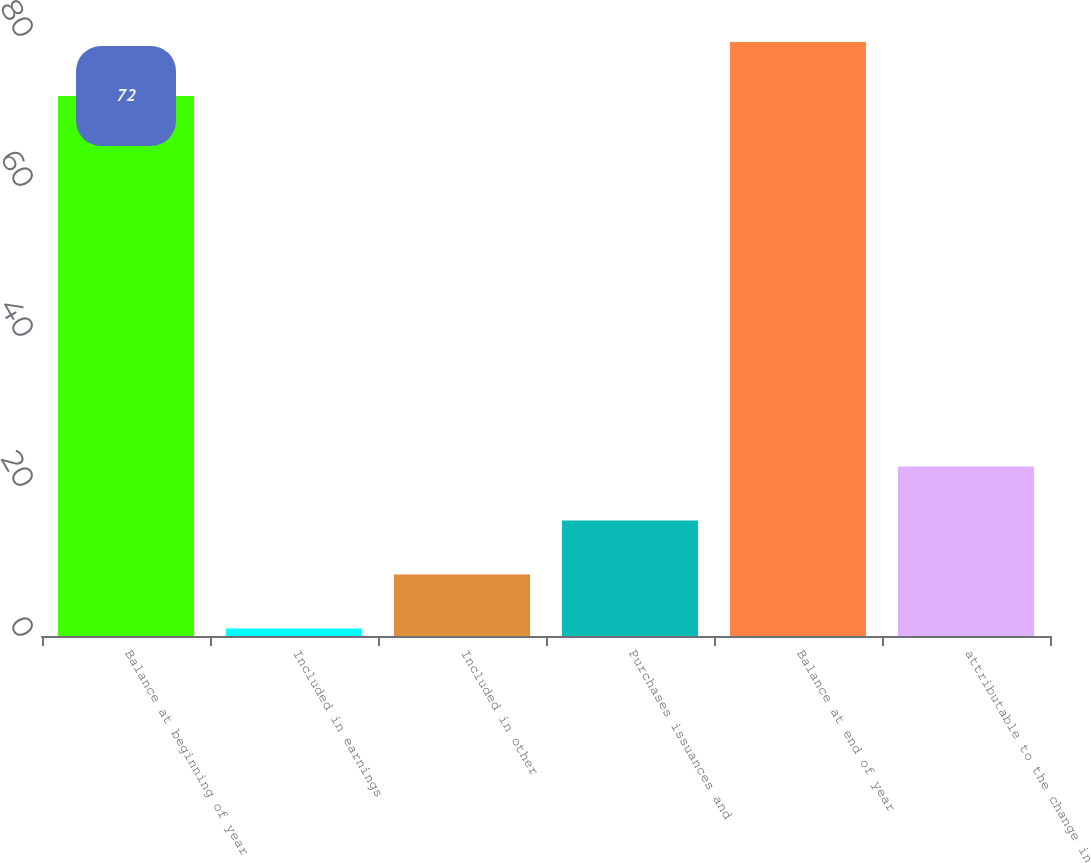Convert chart to OTSL. <chart><loc_0><loc_0><loc_500><loc_500><bar_chart><fcel>Balance at beginning of year<fcel>Included in earnings<fcel>Included in other<fcel>Purchases issuances and<fcel>Balance at end of year<fcel>attributable to the change in<nl><fcel>72<fcel>1<fcel>8.2<fcel>15.4<fcel>79.2<fcel>22.6<nl></chart> 